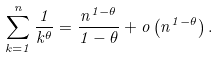Convert formula to latex. <formula><loc_0><loc_0><loc_500><loc_500>\sum _ { k = 1 } ^ { n } \frac { 1 } { k ^ { \theta } } = \frac { n ^ { 1 - \theta } } { 1 - \theta } + o \left ( n ^ { 1 - \theta } \right ) .</formula> 